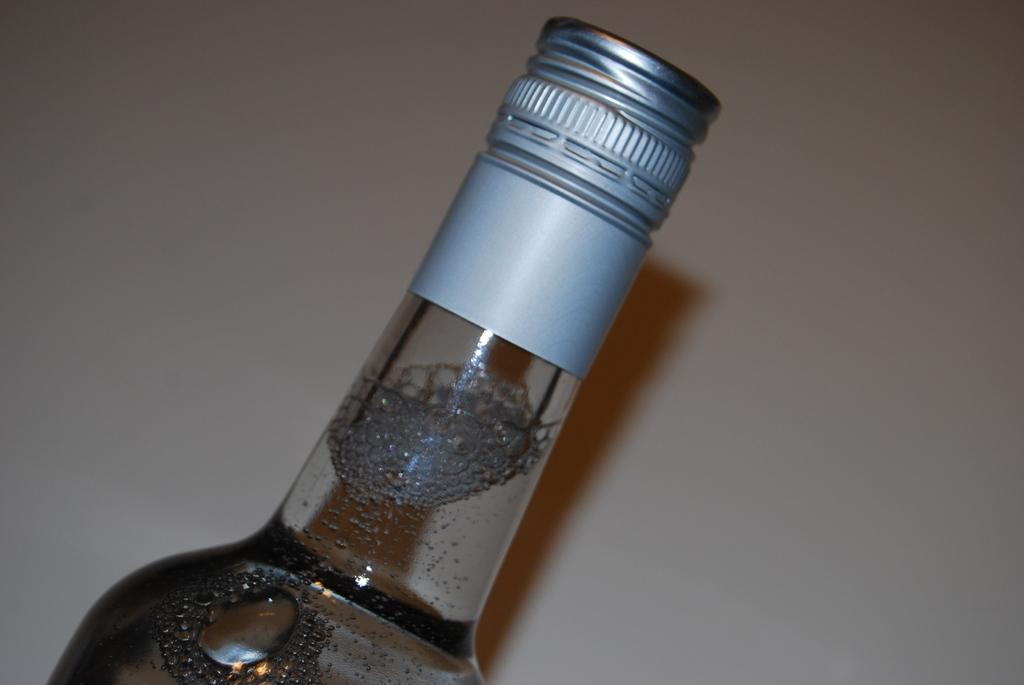What object is visible in the image that is made of glass? There is a glass bottle in the image. How is the glass bottle sealed? The glass bottle is sealed with a silver metal cap. What is inside the glass bottle? There is liquid inside the bottle. What type of iron is being used to answer questions about the image? There is no iron present in the image, nor is it being used to answer questions about the image. 